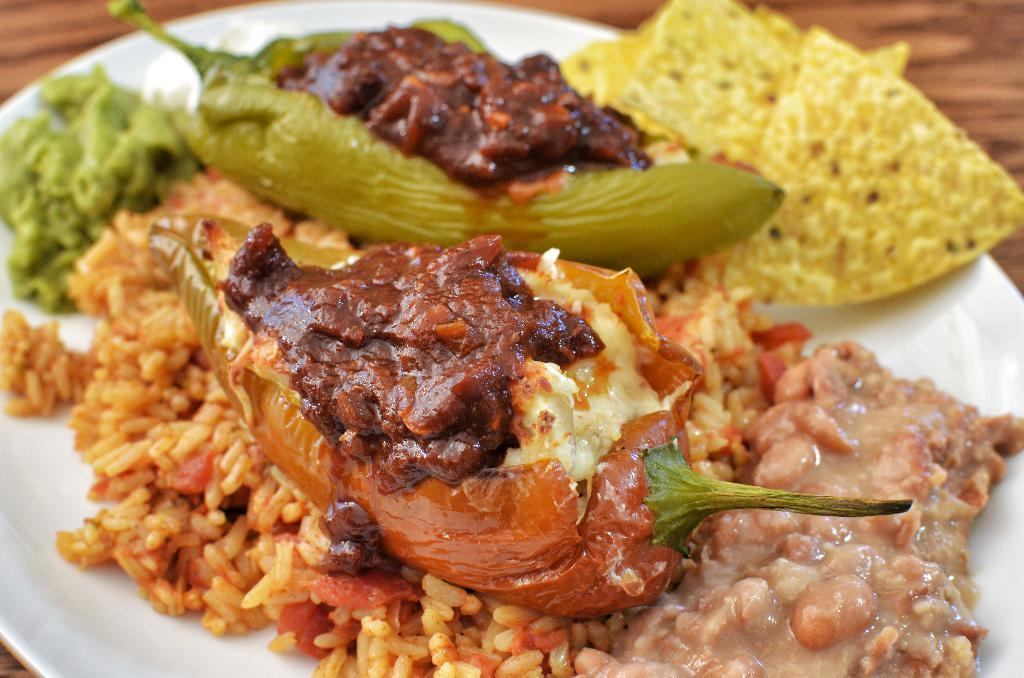What is on the plate that is visible in the image? There are food items on a plate in the image. What type of surface is the plate placed on in the image? There is a wooden surface visible in the image. What month is it in the image? There is no indication of the month in the image. Is there a garden visible in the image? There is no garden present in the image. Can you hear any music or see a band performing in the image? There is no reference to music or a band in the image. 